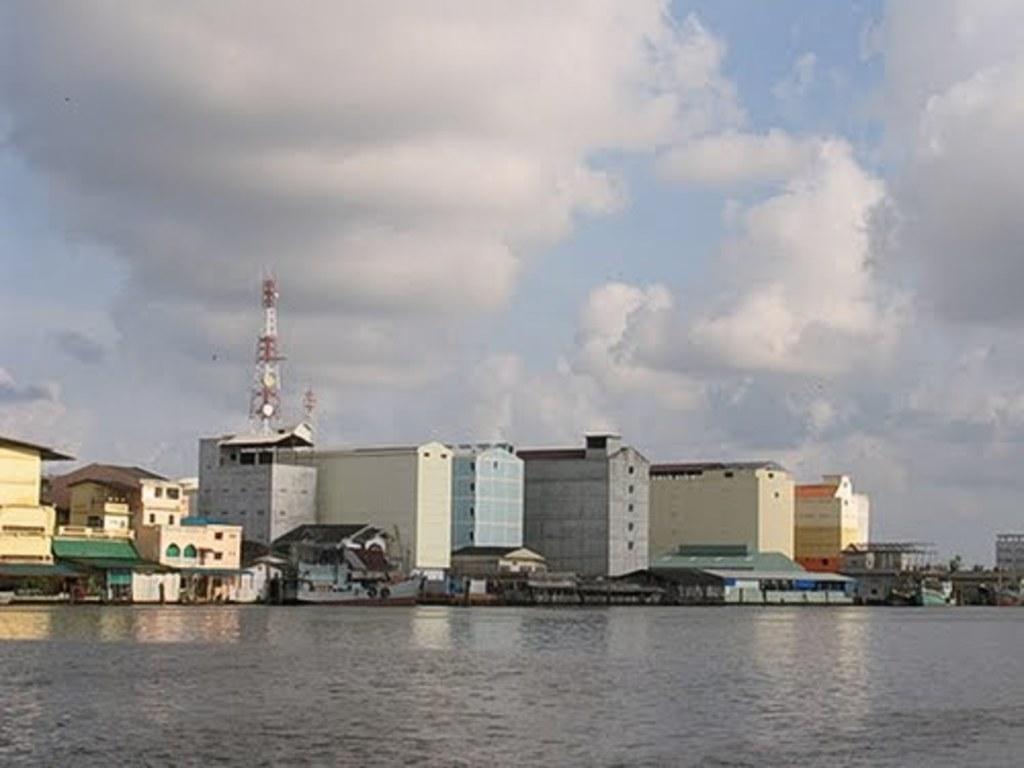Please provide a concise description of this image. In this image we can see lake and buildings. The sky is covered with clouds. Behind the building one tower is there. 